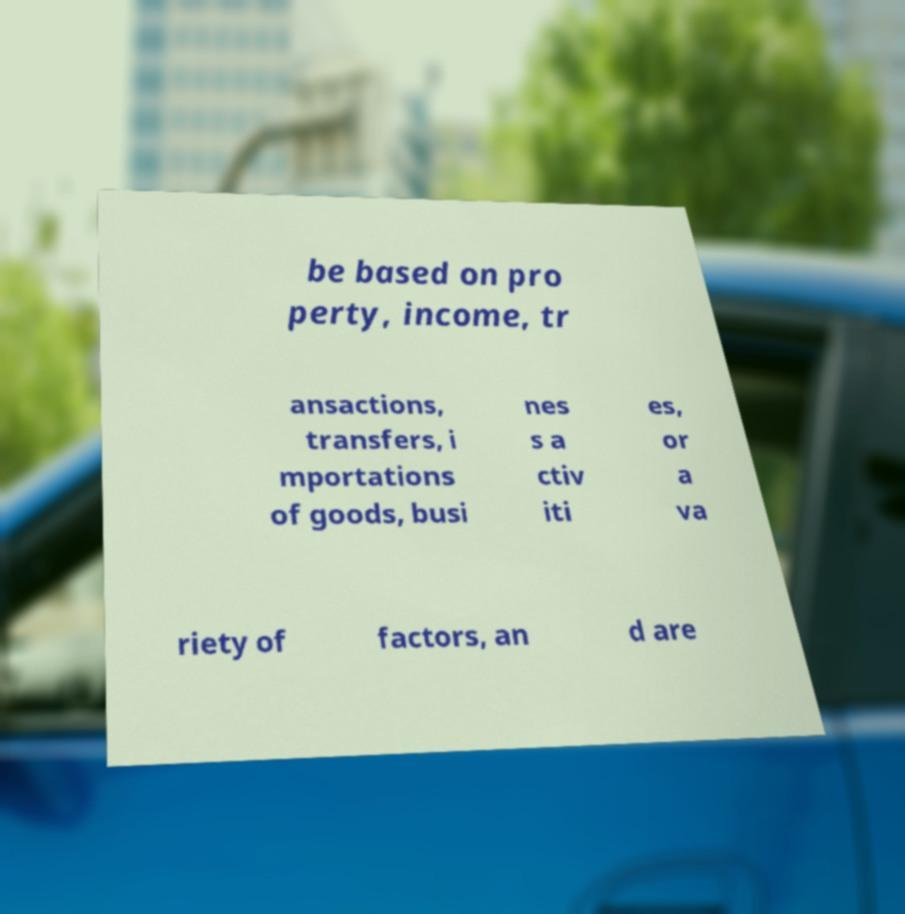Please identify and transcribe the text found in this image. be based on pro perty, income, tr ansactions, transfers, i mportations of goods, busi nes s a ctiv iti es, or a va riety of factors, an d are 